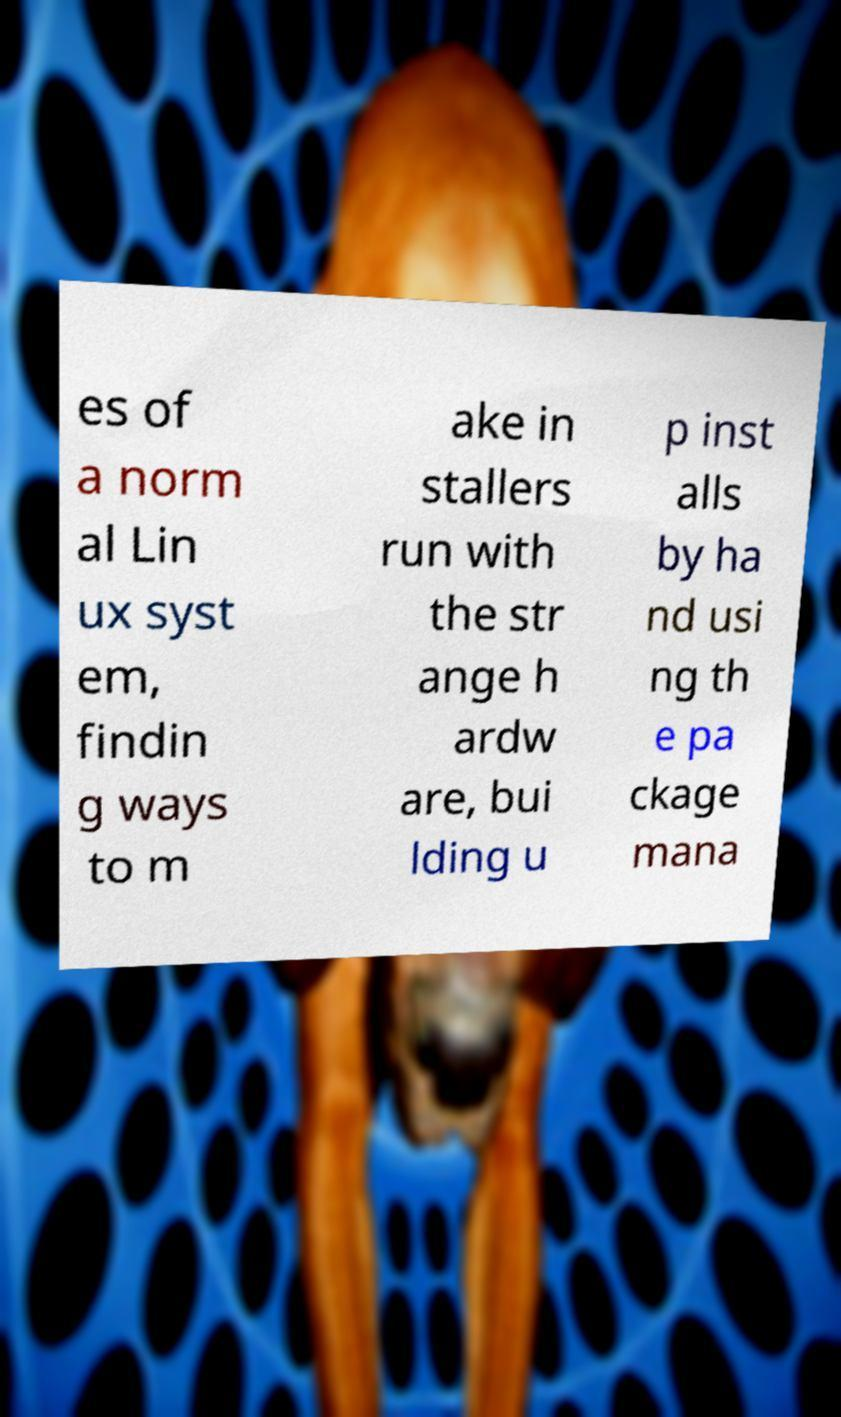Could you assist in decoding the text presented in this image and type it out clearly? es of a norm al Lin ux syst em, findin g ways to m ake in stallers run with the str ange h ardw are, bui lding u p inst alls by ha nd usi ng th e pa ckage mana 